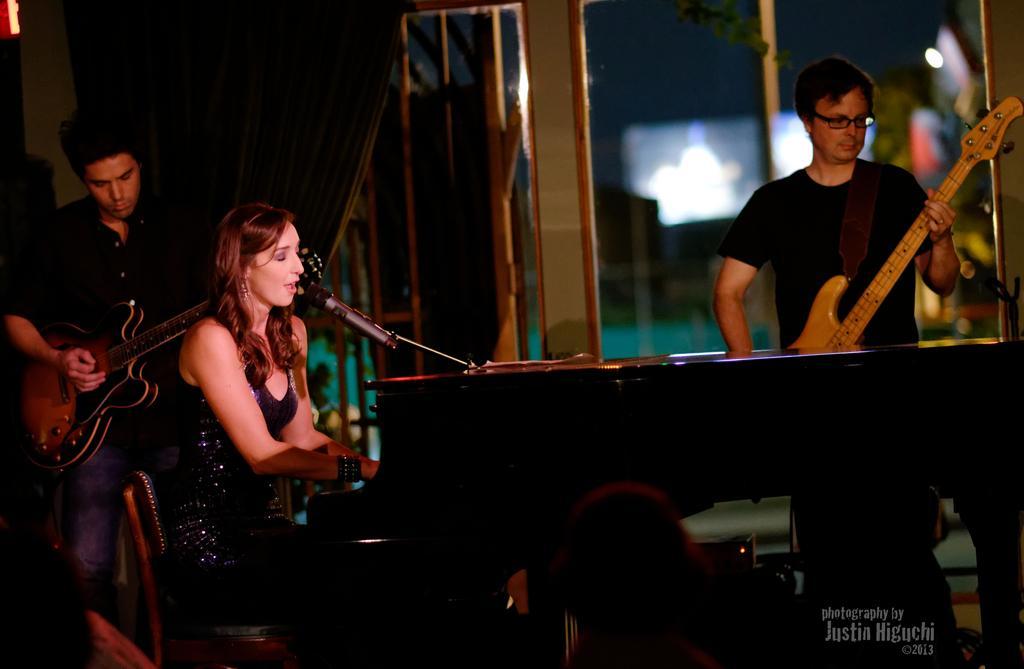Describe this image in one or two sentences. In this picture we can see two boys and one girl, Girl wearing beautiful gown sitting on the chair and playing Wooden color piano and singing in the microphone. Beside we can see boy Wearing black T- shirt playing guitar and on the right a person wearing black shirt also playing Guitar. On behind we can see Big Curtain and glass windows. 